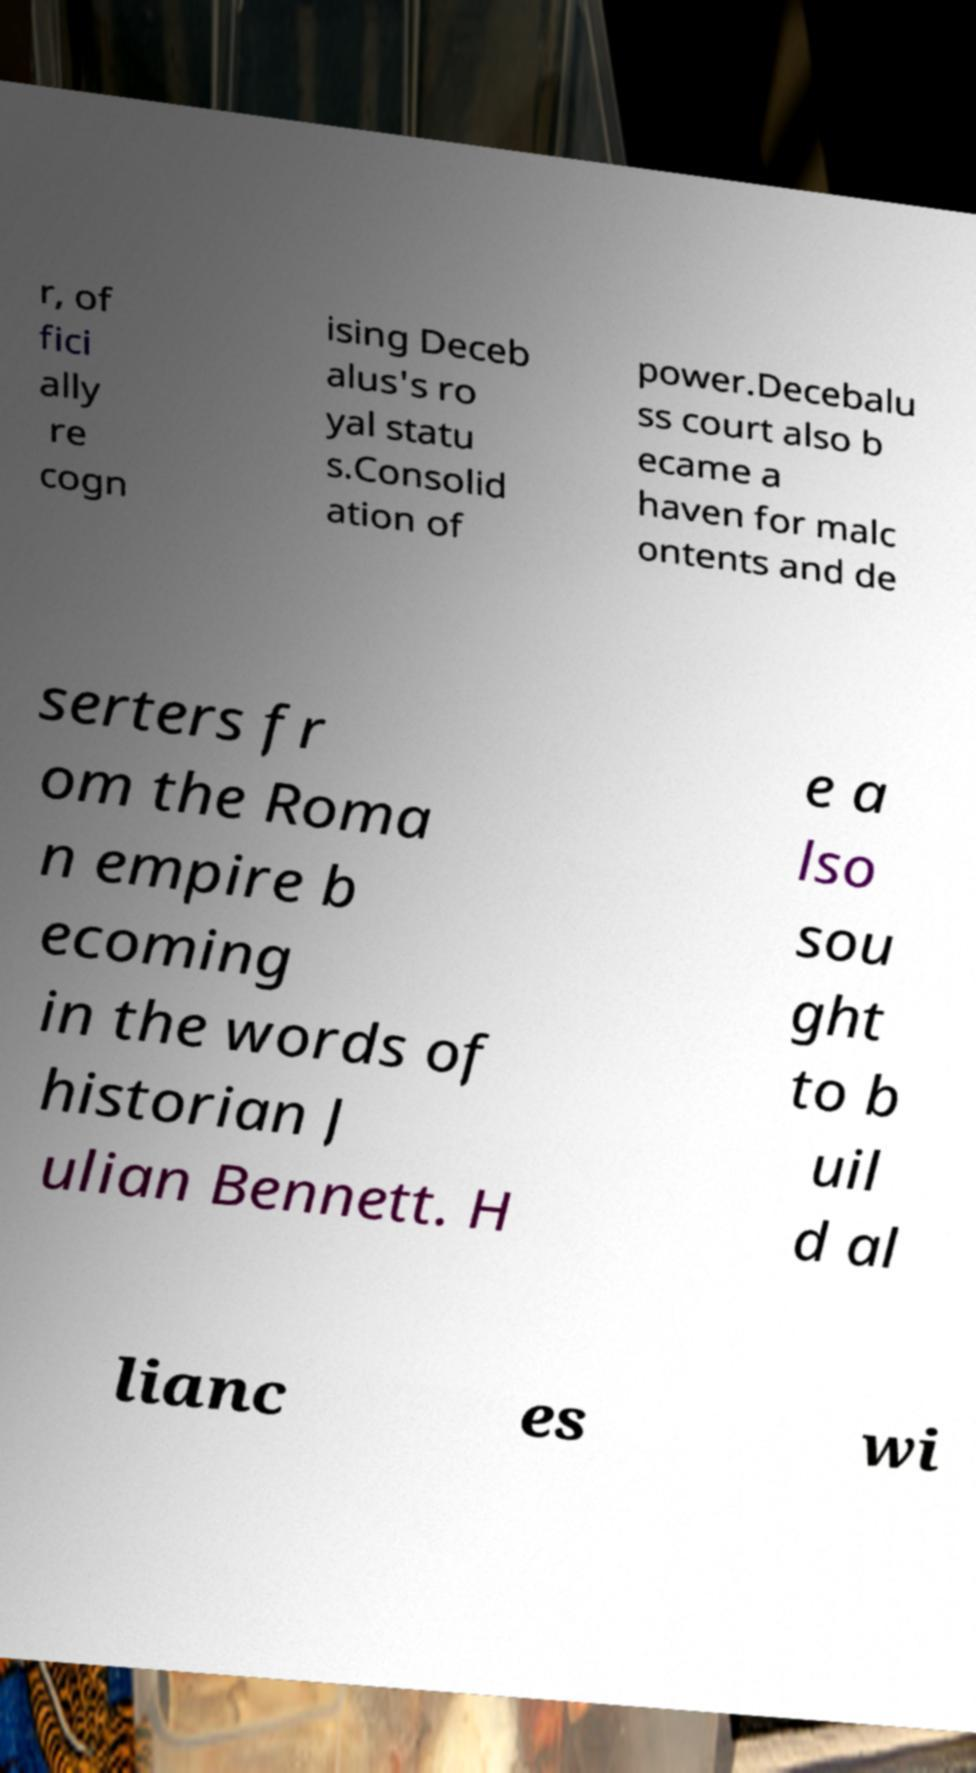Please identify and transcribe the text found in this image. r, of fici ally re cogn ising Deceb alus's ro yal statu s.Consolid ation of power.Decebalu ss court also b ecame a haven for malc ontents and de serters fr om the Roma n empire b ecoming in the words of historian J ulian Bennett. H e a lso sou ght to b uil d al lianc es wi 